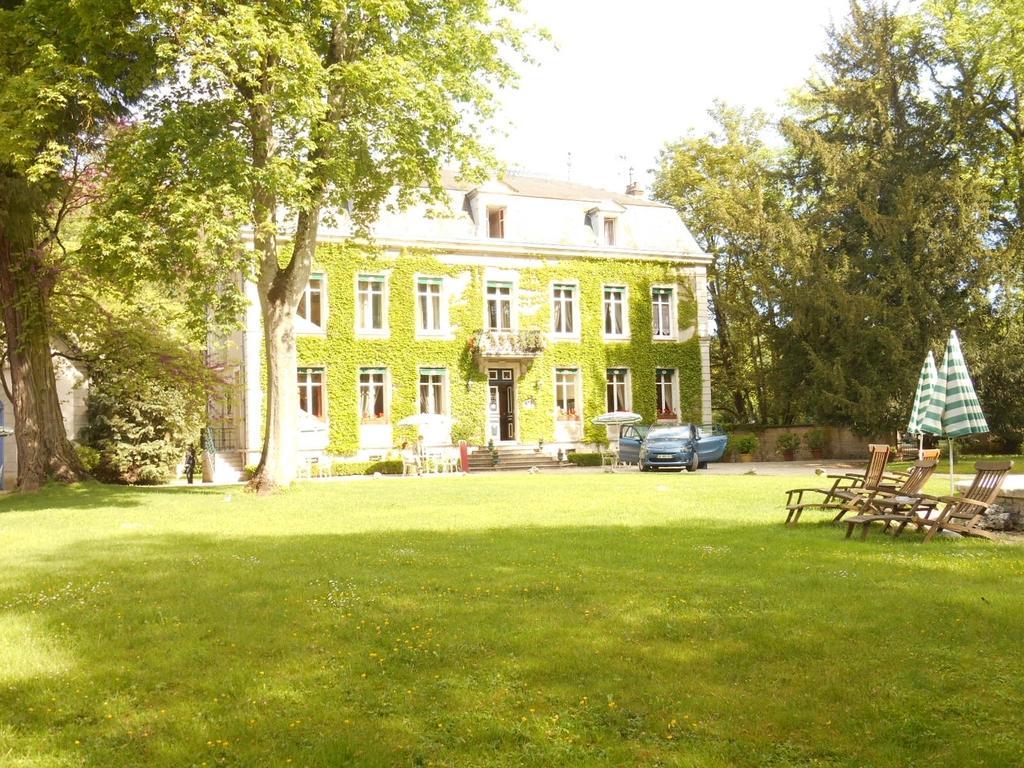Describe this image in one or two sentences. In this image, we can see a house and there are trees, chairs, a car, stairs and there are umbrellas. At the top, there is sky and at the bottom, there is ground. 